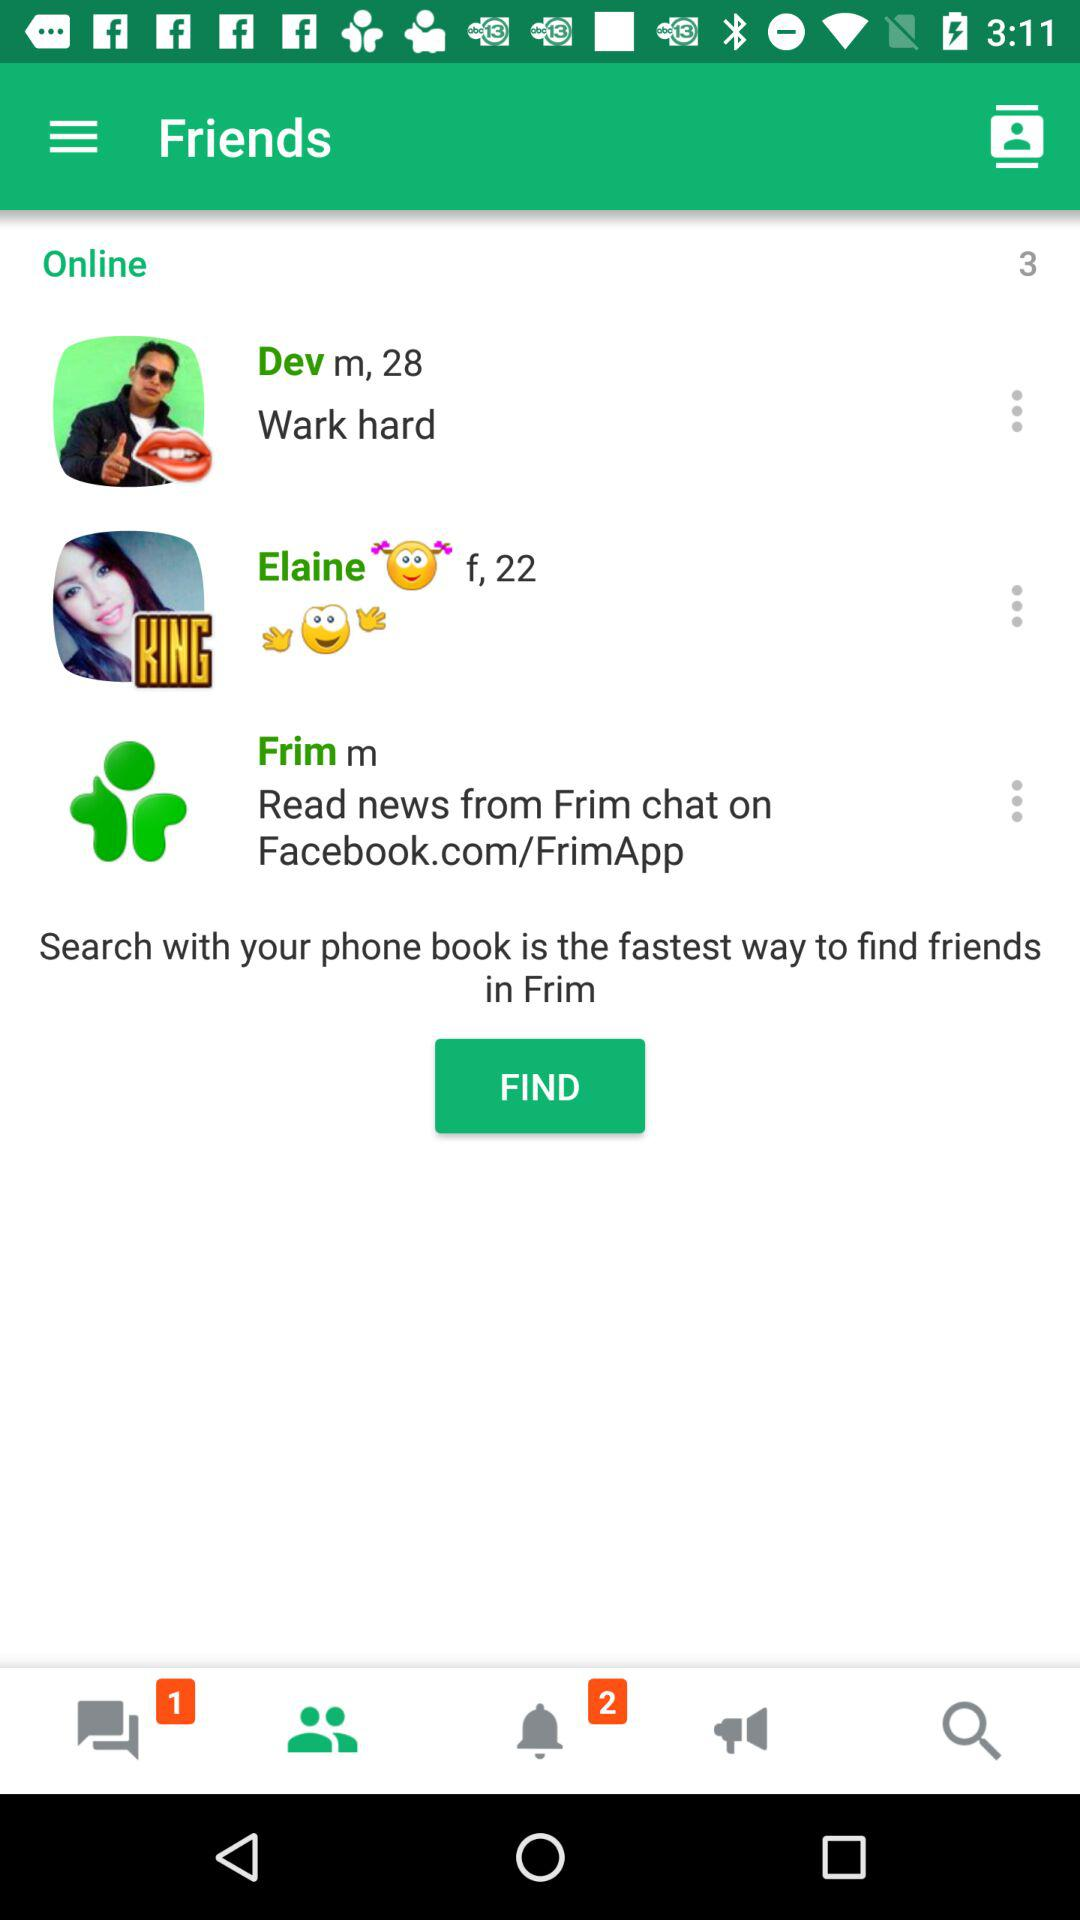How many unread messages are there? There is 1 unread message. 